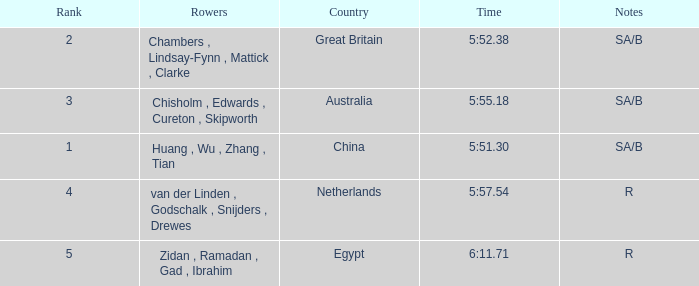Who were the rowers when notes were sa/b, with a time of 5:51.30? Huang , Wu , Zhang , Tian. 